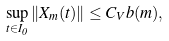Convert formula to latex. <formula><loc_0><loc_0><loc_500><loc_500>\sup _ { t \in I _ { 0 } } \| X _ { m } ( t ) \| \leq C _ { V } b ( m ) ,</formula> 